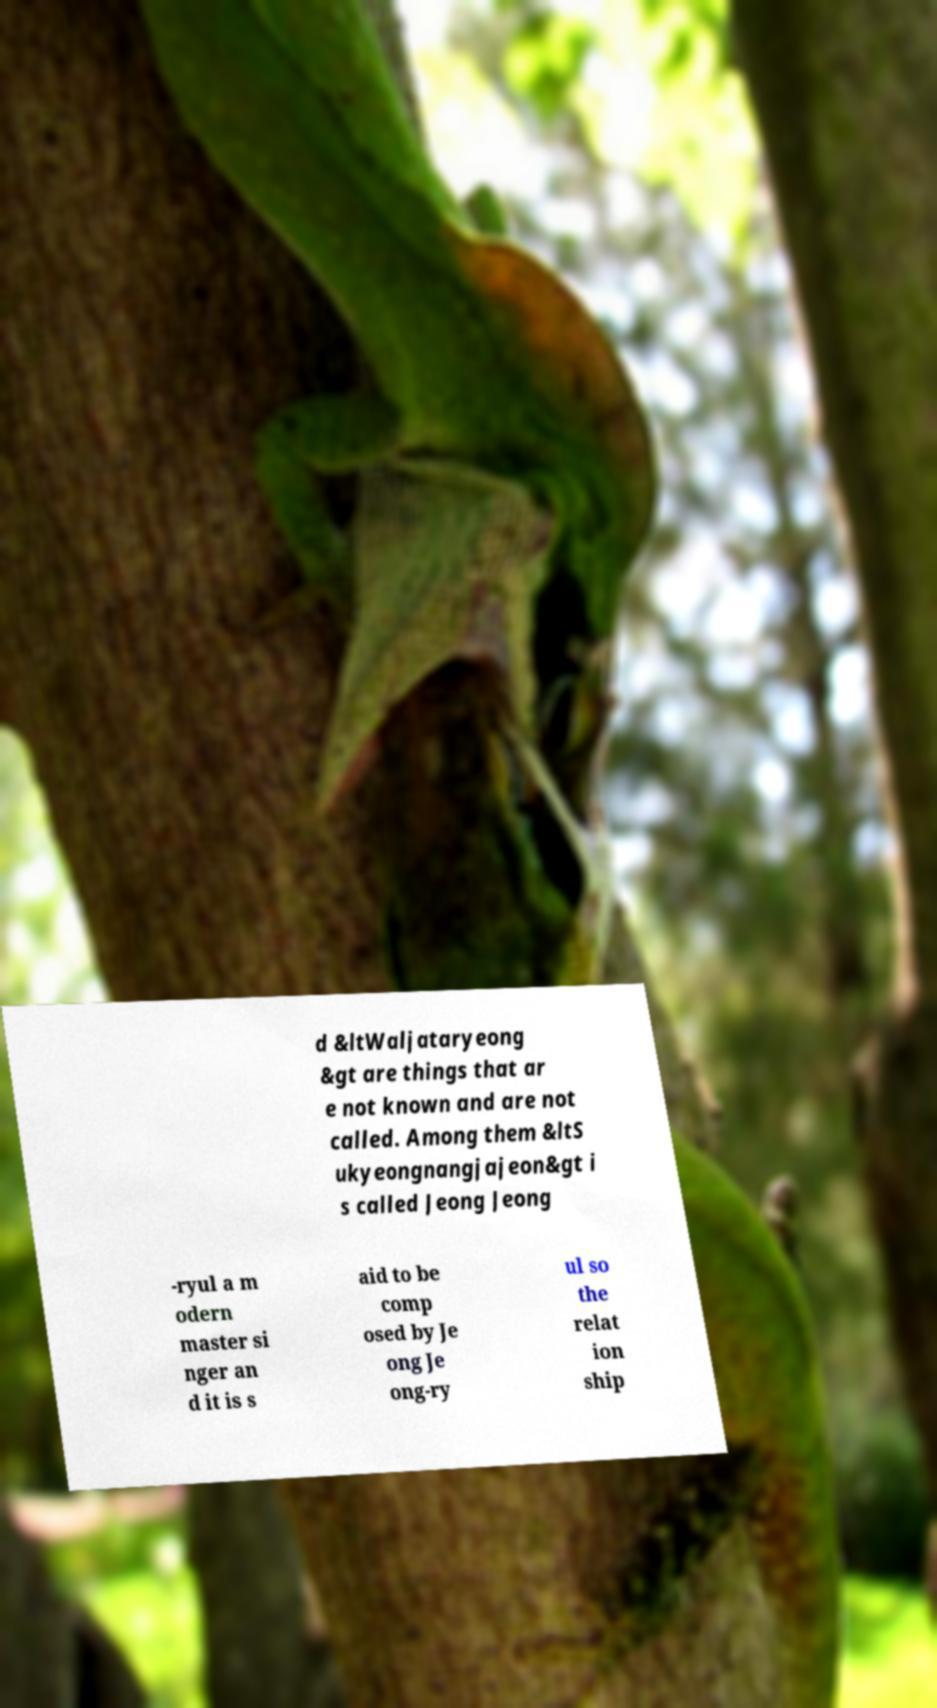Please identify and transcribe the text found in this image. d &ltWaljataryeong &gt are things that ar e not known and are not called. Among them &ltS ukyeongnangjajeon&gt i s called Jeong Jeong -ryul a m odern master si nger an d it is s aid to be comp osed by Je ong Je ong-ry ul so the relat ion ship 